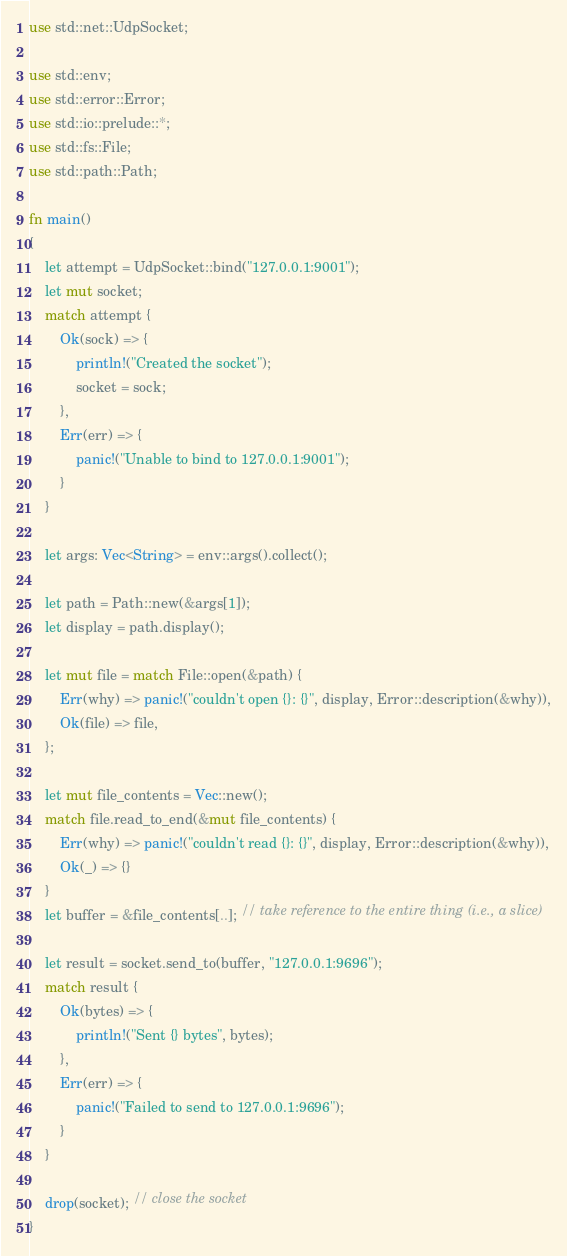<code> <loc_0><loc_0><loc_500><loc_500><_Rust_>use std::net::UdpSocket;

use std::env;
use std::error::Error;
use std::io::prelude::*;
use std::fs::File;
use std::path::Path;

fn main()
{
    let attempt = UdpSocket::bind("127.0.0.1:9001");
    let mut socket;
    match attempt {
        Ok(sock) => {
            println!("Created the socket");
            socket = sock;
        },
        Err(err) => {
            panic!("Unable to bind to 127.0.0.1:9001");
        }
    }

    let args: Vec<String> = env::args().collect();

    let path = Path::new(&args[1]);
    let display = path.display();

    let mut file = match File::open(&path) {
        Err(why) => panic!("couldn't open {}: {}", display, Error::description(&why)),
        Ok(file) => file,
    };

    let mut file_contents = Vec::new();
    match file.read_to_end(&mut file_contents) {
        Err(why) => panic!("couldn't read {}: {}", display, Error::description(&why)),
        Ok(_) => {}
    }
    let buffer = &file_contents[..]; // take reference to the entire thing (i.e., a slice)

    let result = socket.send_to(buffer, "127.0.0.1:9696");
    match result {
        Ok(bytes) => {
            println!("Sent {} bytes", bytes);
        },
        Err(err) => {
            panic!("Failed to send to 127.0.0.1:9696");
        }
    }

    drop(socket); // close the socket
}
</code> 